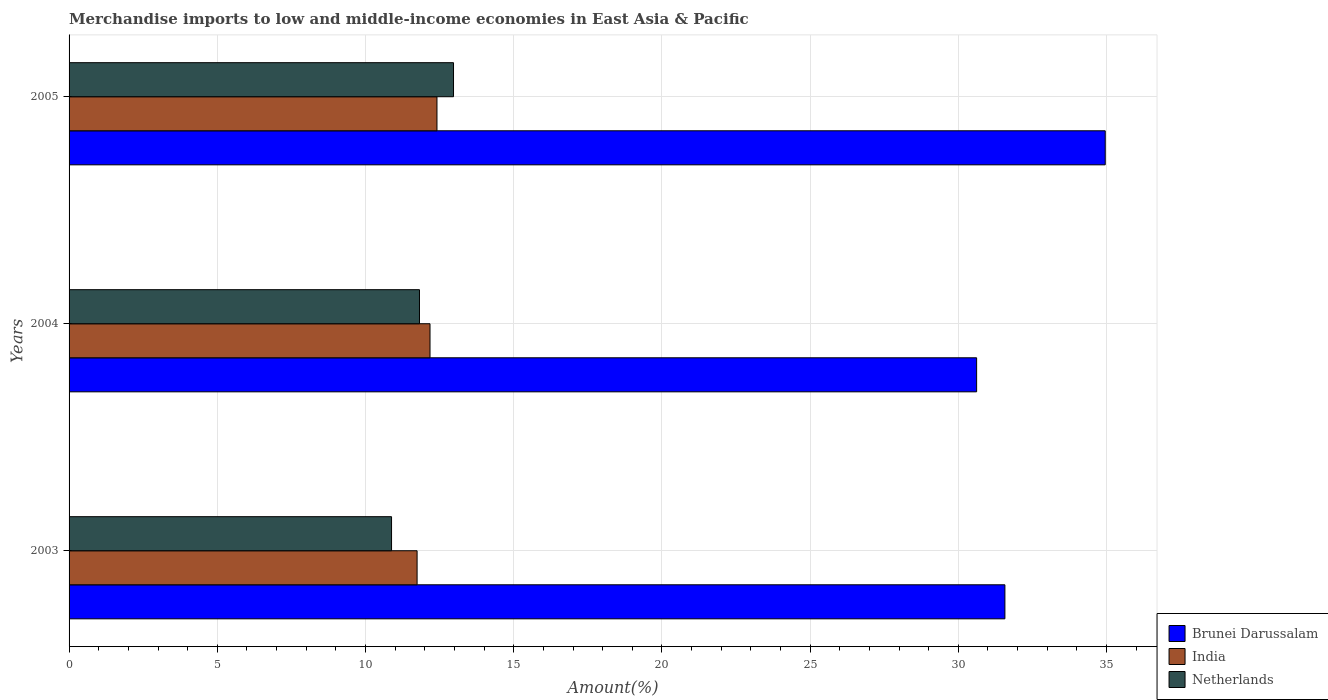How many different coloured bars are there?
Keep it short and to the point. 3. Are the number of bars per tick equal to the number of legend labels?
Keep it short and to the point. Yes. How many bars are there on the 3rd tick from the top?
Offer a terse response. 3. What is the label of the 1st group of bars from the top?
Give a very brief answer. 2005. What is the percentage of amount earned from merchandise imports in India in 2003?
Your response must be concise. 11.74. Across all years, what is the maximum percentage of amount earned from merchandise imports in India?
Offer a terse response. 12.41. Across all years, what is the minimum percentage of amount earned from merchandise imports in Brunei Darussalam?
Make the answer very short. 30.62. What is the total percentage of amount earned from merchandise imports in India in the graph?
Make the answer very short. 36.33. What is the difference between the percentage of amount earned from merchandise imports in India in 2004 and that in 2005?
Provide a short and direct response. -0.23. What is the difference between the percentage of amount earned from merchandise imports in Brunei Darussalam in 2004 and the percentage of amount earned from merchandise imports in India in 2005?
Make the answer very short. 18.21. What is the average percentage of amount earned from merchandise imports in Netherlands per year?
Your answer should be very brief. 11.89. In the year 2004, what is the difference between the percentage of amount earned from merchandise imports in Brunei Darussalam and percentage of amount earned from merchandise imports in Netherlands?
Give a very brief answer. 18.8. What is the ratio of the percentage of amount earned from merchandise imports in India in 2004 to that in 2005?
Make the answer very short. 0.98. Is the percentage of amount earned from merchandise imports in Netherlands in 2003 less than that in 2004?
Give a very brief answer. Yes. Is the difference between the percentage of amount earned from merchandise imports in Brunei Darussalam in 2004 and 2005 greater than the difference between the percentage of amount earned from merchandise imports in Netherlands in 2004 and 2005?
Provide a succinct answer. No. What is the difference between the highest and the second highest percentage of amount earned from merchandise imports in India?
Your answer should be very brief. 0.23. What is the difference between the highest and the lowest percentage of amount earned from merchandise imports in Netherlands?
Offer a very short reply. 2.09. In how many years, is the percentage of amount earned from merchandise imports in India greater than the average percentage of amount earned from merchandise imports in India taken over all years?
Make the answer very short. 2. Is it the case that in every year, the sum of the percentage of amount earned from merchandise imports in India and percentage of amount earned from merchandise imports in Netherlands is greater than the percentage of amount earned from merchandise imports in Brunei Darussalam?
Offer a terse response. No. How many years are there in the graph?
Provide a short and direct response. 3. What is the difference between two consecutive major ticks on the X-axis?
Ensure brevity in your answer.  5. How many legend labels are there?
Ensure brevity in your answer.  3. How are the legend labels stacked?
Your answer should be very brief. Vertical. What is the title of the graph?
Give a very brief answer. Merchandise imports to low and middle-income economies in East Asia & Pacific. Does "Latvia" appear as one of the legend labels in the graph?
Make the answer very short. No. What is the label or title of the X-axis?
Ensure brevity in your answer.  Amount(%). What is the label or title of the Y-axis?
Offer a very short reply. Years. What is the Amount(%) of Brunei Darussalam in 2003?
Make the answer very short. 31.57. What is the Amount(%) of India in 2003?
Provide a short and direct response. 11.74. What is the Amount(%) of Netherlands in 2003?
Your response must be concise. 10.88. What is the Amount(%) of Brunei Darussalam in 2004?
Provide a succinct answer. 30.62. What is the Amount(%) of India in 2004?
Offer a very short reply. 12.18. What is the Amount(%) in Netherlands in 2004?
Your response must be concise. 11.82. What is the Amount(%) in Brunei Darussalam in 2005?
Your response must be concise. 34.96. What is the Amount(%) of India in 2005?
Your answer should be very brief. 12.41. What is the Amount(%) of Netherlands in 2005?
Keep it short and to the point. 12.97. Across all years, what is the maximum Amount(%) in Brunei Darussalam?
Offer a very short reply. 34.96. Across all years, what is the maximum Amount(%) in India?
Give a very brief answer. 12.41. Across all years, what is the maximum Amount(%) in Netherlands?
Your response must be concise. 12.97. Across all years, what is the minimum Amount(%) in Brunei Darussalam?
Make the answer very short. 30.62. Across all years, what is the minimum Amount(%) in India?
Offer a terse response. 11.74. Across all years, what is the minimum Amount(%) of Netherlands?
Ensure brevity in your answer.  10.88. What is the total Amount(%) in Brunei Darussalam in the graph?
Provide a short and direct response. 97.14. What is the total Amount(%) in India in the graph?
Keep it short and to the point. 36.33. What is the total Amount(%) in Netherlands in the graph?
Provide a succinct answer. 35.67. What is the difference between the Amount(%) in Brunei Darussalam in 2003 and that in 2004?
Keep it short and to the point. 0.95. What is the difference between the Amount(%) in India in 2003 and that in 2004?
Your answer should be compact. -0.44. What is the difference between the Amount(%) in Netherlands in 2003 and that in 2004?
Your response must be concise. -0.94. What is the difference between the Amount(%) of Brunei Darussalam in 2003 and that in 2005?
Your response must be concise. -3.38. What is the difference between the Amount(%) in India in 2003 and that in 2005?
Offer a very short reply. -0.67. What is the difference between the Amount(%) in Netherlands in 2003 and that in 2005?
Keep it short and to the point. -2.09. What is the difference between the Amount(%) in Brunei Darussalam in 2004 and that in 2005?
Your answer should be compact. -4.34. What is the difference between the Amount(%) in India in 2004 and that in 2005?
Ensure brevity in your answer.  -0.23. What is the difference between the Amount(%) in Netherlands in 2004 and that in 2005?
Ensure brevity in your answer.  -1.15. What is the difference between the Amount(%) of Brunei Darussalam in 2003 and the Amount(%) of India in 2004?
Your response must be concise. 19.39. What is the difference between the Amount(%) in Brunei Darussalam in 2003 and the Amount(%) in Netherlands in 2004?
Make the answer very short. 19.75. What is the difference between the Amount(%) of India in 2003 and the Amount(%) of Netherlands in 2004?
Provide a succinct answer. -0.08. What is the difference between the Amount(%) in Brunei Darussalam in 2003 and the Amount(%) in India in 2005?
Make the answer very short. 19.16. What is the difference between the Amount(%) of Brunei Darussalam in 2003 and the Amount(%) of Netherlands in 2005?
Keep it short and to the point. 18.6. What is the difference between the Amount(%) in India in 2003 and the Amount(%) in Netherlands in 2005?
Your response must be concise. -1.23. What is the difference between the Amount(%) of Brunei Darussalam in 2004 and the Amount(%) of India in 2005?
Your answer should be very brief. 18.21. What is the difference between the Amount(%) of Brunei Darussalam in 2004 and the Amount(%) of Netherlands in 2005?
Provide a short and direct response. 17.65. What is the difference between the Amount(%) in India in 2004 and the Amount(%) in Netherlands in 2005?
Give a very brief answer. -0.79. What is the average Amount(%) in Brunei Darussalam per year?
Offer a terse response. 32.38. What is the average Amount(%) of India per year?
Provide a short and direct response. 12.11. What is the average Amount(%) in Netherlands per year?
Your response must be concise. 11.89. In the year 2003, what is the difference between the Amount(%) in Brunei Darussalam and Amount(%) in India?
Keep it short and to the point. 19.83. In the year 2003, what is the difference between the Amount(%) in Brunei Darussalam and Amount(%) in Netherlands?
Provide a short and direct response. 20.69. In the year 2003, what is the difference between the Amount(%) in India and Amount(%) in Netherlands?
Your answer should be compact. 0.86. In the year 2004, what is the difference between the Amount(%) in Brunei Darussalam and Amount(%) in India?
Ensure brevity in your answer.  18.44. In the year 2004, what is the difference between the Amount(%) in Brunei Darussalam and Amount(%) in Netherlands?
Your answer should be very brief. 18.8. In the year 2004, what is the difference between the Amount(%) in India and Amount(%) in Netherlands?
Offer a very short reply. 0.36. In the year 2005, what is the difference between the Amount(%) of Brunei Darussalam and Amount(%) of India?
Your answer should be very brief. 22.54. In the year 2005, what is the difference between the Amount(%) of Brunei Darussalam and Amount(%) of Netherlands?
Provide a succinct answer. 21.99. In the year 2005, what is the difference between the Amount(%) of India and Amount(%) of Netherlands?
Keep it short and to the point. -0.56. What is the ratio of the Amount(%) of Brunei Darussalam in 2003 to that in 2004?
Provide a short and direct response. 1.03. What is the ratio of the Amount(%) in India in 2003 to that in 2004?
Provide a succinct answer. 0.96. What is the ratio of the Amount(%) in Netherlands in 2003 to that in 2004?
Provide a short and direct response. 0.92. What is the ratio of the Amount(%) in Brunei Darussalam in 2003 to that in 2005?
Your response must be concise. 0.9. What is the ratio of the Amount(%) of India in 2003 to that in 2005?
Ensure brevity in your answer.  0.95. What is the ratio of the Amount(%) in Netherlands in 2003 to that in 2005?
Keep it short and to the point. 0.84. What is the ratio of the Amount(%) in Brunei Darussalam in 2004 to that in 2005?
Give a very brief answer. 0.88. What is the ratio of the Amount(%) in India in 2004 to that in 2005?
Provide a short and direct response. 0.98. What is the ratio of the Amount(%) in Netherlands in 2004 to that in 2005?
Your response must be concise. 0.91. What is the difference between the highest and the second highest Amount(%) of Brunei Darussalam?
Offer a very short reply. 3.38. What is the difference between the highest and the second highest Amount(%) in India?
Provide a short and direct response. 0.23. What is the difference between the highest and the second highest Amount(%) of Netherlands?
Make the answer very short. 1.15. What is the difference between the highest and the lowest Amount(%) of Brunei Darussalam?
Your answer should be very brief. 4.34. What is the difference between the highest and the lowest Amount(%) of India?
Offer a terse response. 0.67. What is the difference between the highest and the lowest Amount(%) of Netherlands?
Your answer should be compact. 2.09. 